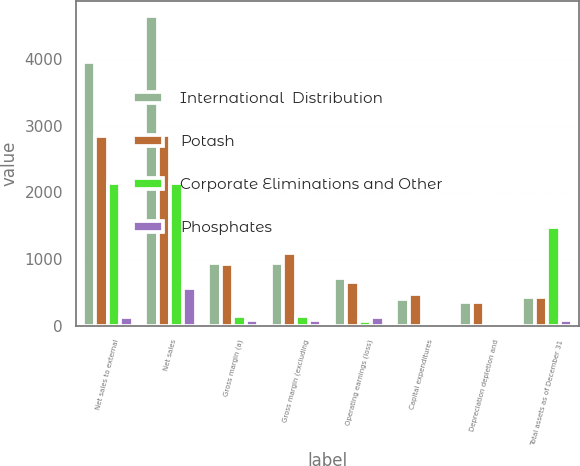<chart> <loc_0><loc_0><loc_500><loc_500><stacked_bar_chart><ecel><fcel>Net sales to external<fcel>Net sales<fcel>Gross margin (a)<fcel>Gross margin (excluding<fcel>Operating earnings (loss)<fcel>Capital expenditures<fcel>Depreciation depletion and<fcel>Total assets as of December 31<nl><fcel>International  Distribution<fcel>3946.8<fcel>4637.1<fcel>937.1<fcel>937.1<fcel>709.2<fcel>403.6<fcel>359.7<fcel>437.15<nl><fcel>Potash<fcel>2839.9<fcel>2851.6<fcel>923.2<fcel>1091.6<fcel>656.2<fcel>470.7<fcel>355.1<fcel>437.15<nl><fcel>Corporate Eliminations and Other<fcel>2132.8<fcel>2134.5<fcel>147.2<fcel>147.2<fcel>75.7<fcel>35.4<fcel>8.6<fcel>1477.1<nl><fcel>Phosphates<fcel>136.3<fcel>567.4<fcel>80.9<fcel>80.9<fcel>129.3<fcel>19.4<fcel>27.5<fcel>94<nl></chart> 